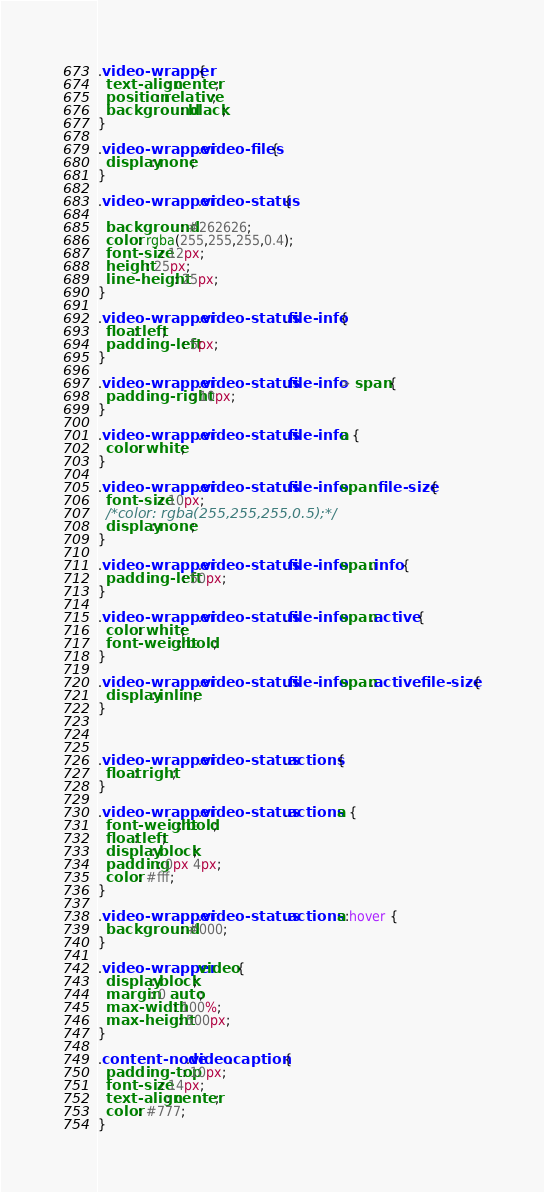Convert code to text. <code><loc_0><loc_0><loc_500><loc_500><_CSS_>.video-wrapper {
  text-align: center;
  position: relative;
  background: black;
}

.video-wrapper .video-files {
  display: none;
}

.video-wrapper .video-status {

  background: #262626;
  color: rgba(255,255,255,0.4);
  font-size: 12px;
  height: 25px;
  line-height: 25px;
}

.video-wrapper .video-status .file-info {
  float: left;
  padding-left: 5px;
}

.video-wrapper .video-status .file-info > span {
  padding-right: 10px;
}

.video-wrapper .video-status .file-info a {
  color: white;
}

.video-wrapper .video-status .file-info span .file-size {
  font-size: 10px;
  /*color: rgba(255,255,255,0.5);*/
  display: none;
}

.video-wrapper .video-status .file-info span.info {
  padding-left: 50px;
}

.video-wrapper .video-status .file-info span.active {
  color: white;
  font-weight: bold;
}

.video-wrapper .video-status .file-info span.active .file-size {
  display: inline;
}



.video-wrapper .video-status .actions {
  float: right;
}

.video-wrapper .video-status .actions a {
  font-weight: bold;
  float: left;
  display: block;
  padding: 0px 4px;
  color: #fff;
}

.video-wrapper .video-status .actions a:hover {
  background: #000;
}

.video-wrapper video {
  display: block;
  margin: 0 auto;
  max-width: 100%;
  max-height: 500px;
}

.content-node.video .caption {
  padding-top: 10px;
  font-size: 14px;
  text-align: center;
  color: #777;
}</code> 